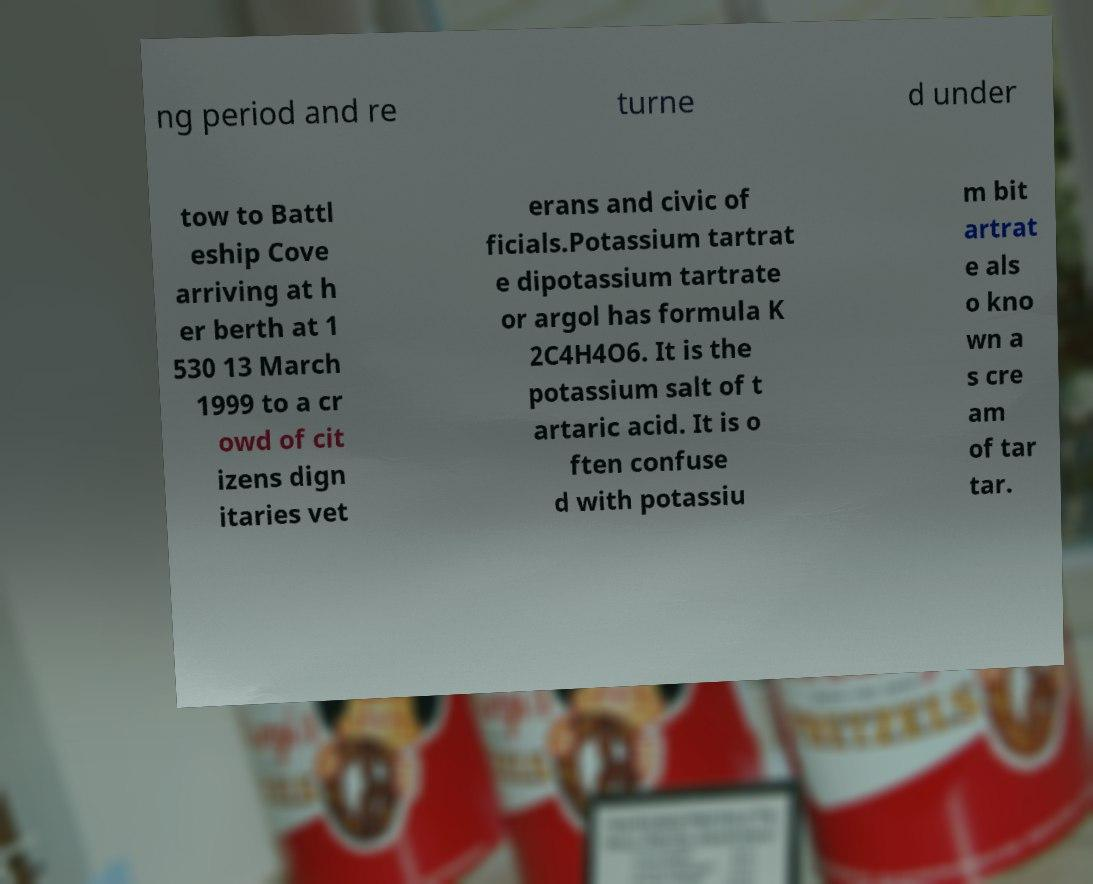Could you assist in decoding the text presented in this image and type it out clearly? ng period and re turne d under tow to Battl eship Cove arriving at h er berth at 1 530 13 March 1999 to a cr owd of cit izens dign itaries vet erans and civic of ficials.Potassium tartrat e dipotassium tartrate or argol has formula K 2C4H4O6. It is the potassium salt of t artaric acid. It is o ften confuse d with potassiu m bit artrat e als o kno wn a s cre am of tar tar. 